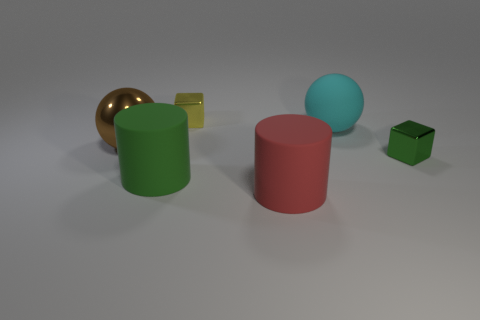What is the shape of the yellow metal thing that is the same size as the green metallic object?
Provide a succinct answer. Cube. There is a small block on the left side of the large cyan rubber thing; how many small yellow metal things are in front of it?
Keep it short and to the point. 0. There is a rubber object that is behind the red matte thing and in front of the large cyan thing; what is its size?
Your response must be concise. Large. Is there a red rubber object of the same size as the cyan rubber ball?
Provide a succinct answer. Yes. Is the number of objects on the left side of the large rubber sphere greater than the number of matte objects in front of the large brown sphere?
Your answer should be very brief. Yes. Are the green block and the big ball on the left side of the large red rubber cylinder made of the same material?
Provide a short and direct response. Yes. How many green things are to the right of the tiny metal cube that is right of the metallic cube that is on the left side of the cyan thing?
Give a very brief answer. 0. There is a large green matte object; does it have the same shape as the tiny thing that is behind the big brown ball?
Offer a terse response. No. The large matte thing that is in front of the large rubber sphere and right of the yellow shiny block is what color?
Offer a terse response. Red. There is a cube on the right side of the big cyan ball behind the green thing that is left of the tiny yellow metallic thing; what is its material?
Provide a short and direct response. Metal. 